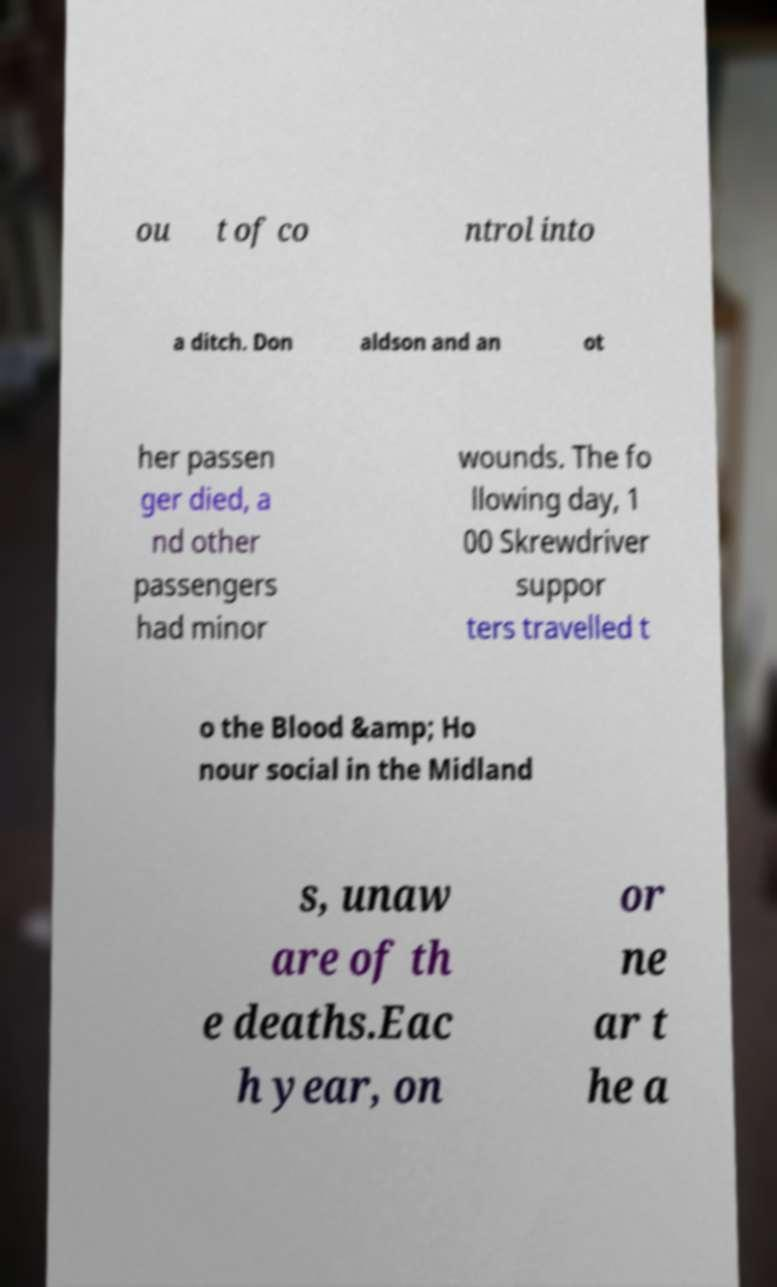Could you extract and type out the text from this image? ou t of co ntrol into a ditch. Don aldson and an ot her passen ger died, a nd other passengers had minor wounds. The fo llowing day, 1 00 Skrewdriver suppor ters travelled t o the Blood &amp; Ho nour social in the Midland s, unaw are of th e deaths.Eac h year, on or ne ar t he a 